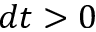<formula> <loc_0><loc_0><loc_500><loc_500>d t > 0</formula> 